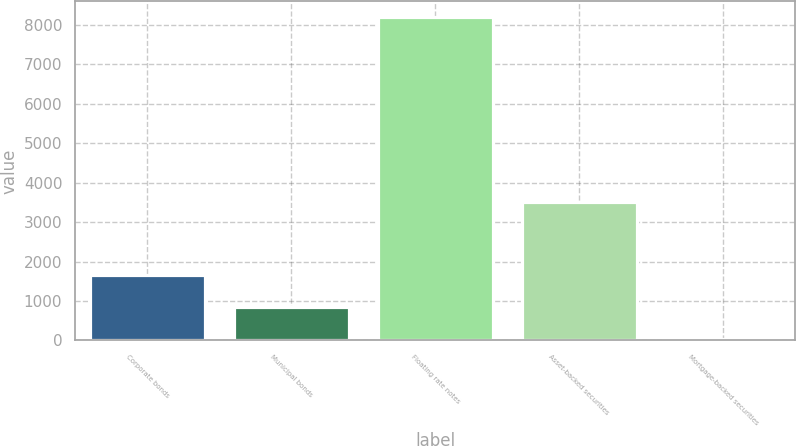<chart> <loc_0><loc_0><loc_500><loc_500><bar_chart><fcel>Corporate bonds<fcel>Municipal bonds<fcel>Floating rate notes<fcel>Asset-backed securities<fcel>Mortgage-backed securities<nl><fcel>1671.2<fcel>856.6<fcel>8188<fcel>3509<fcel>42<nl></chart> 